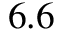Convert formula to latex. <formula><loc_0><loc_0><loc_500><loc_500>6 . 6</formula> 